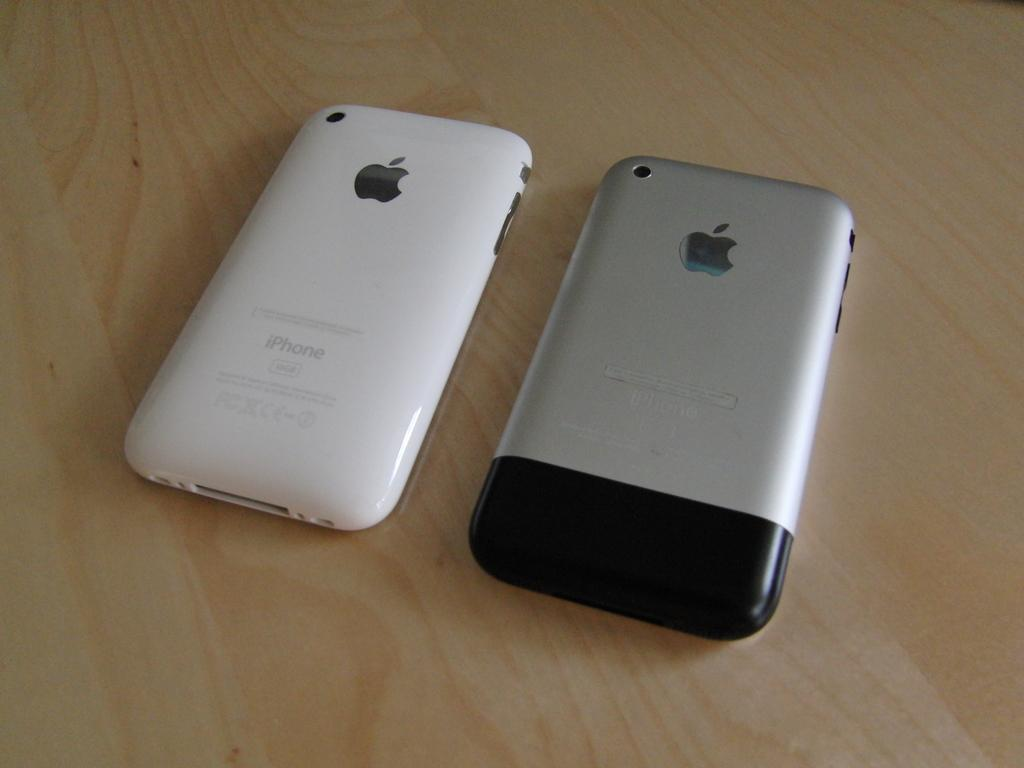How many mobiles can be seen in the image? There are two mobiles in the image. What is the surface on which the mobiles are placed? The mobiles are on a wooden surface. What is the hope of the mobiles in the image? The mobiles do not have hopes, as they are inanimate objects. 